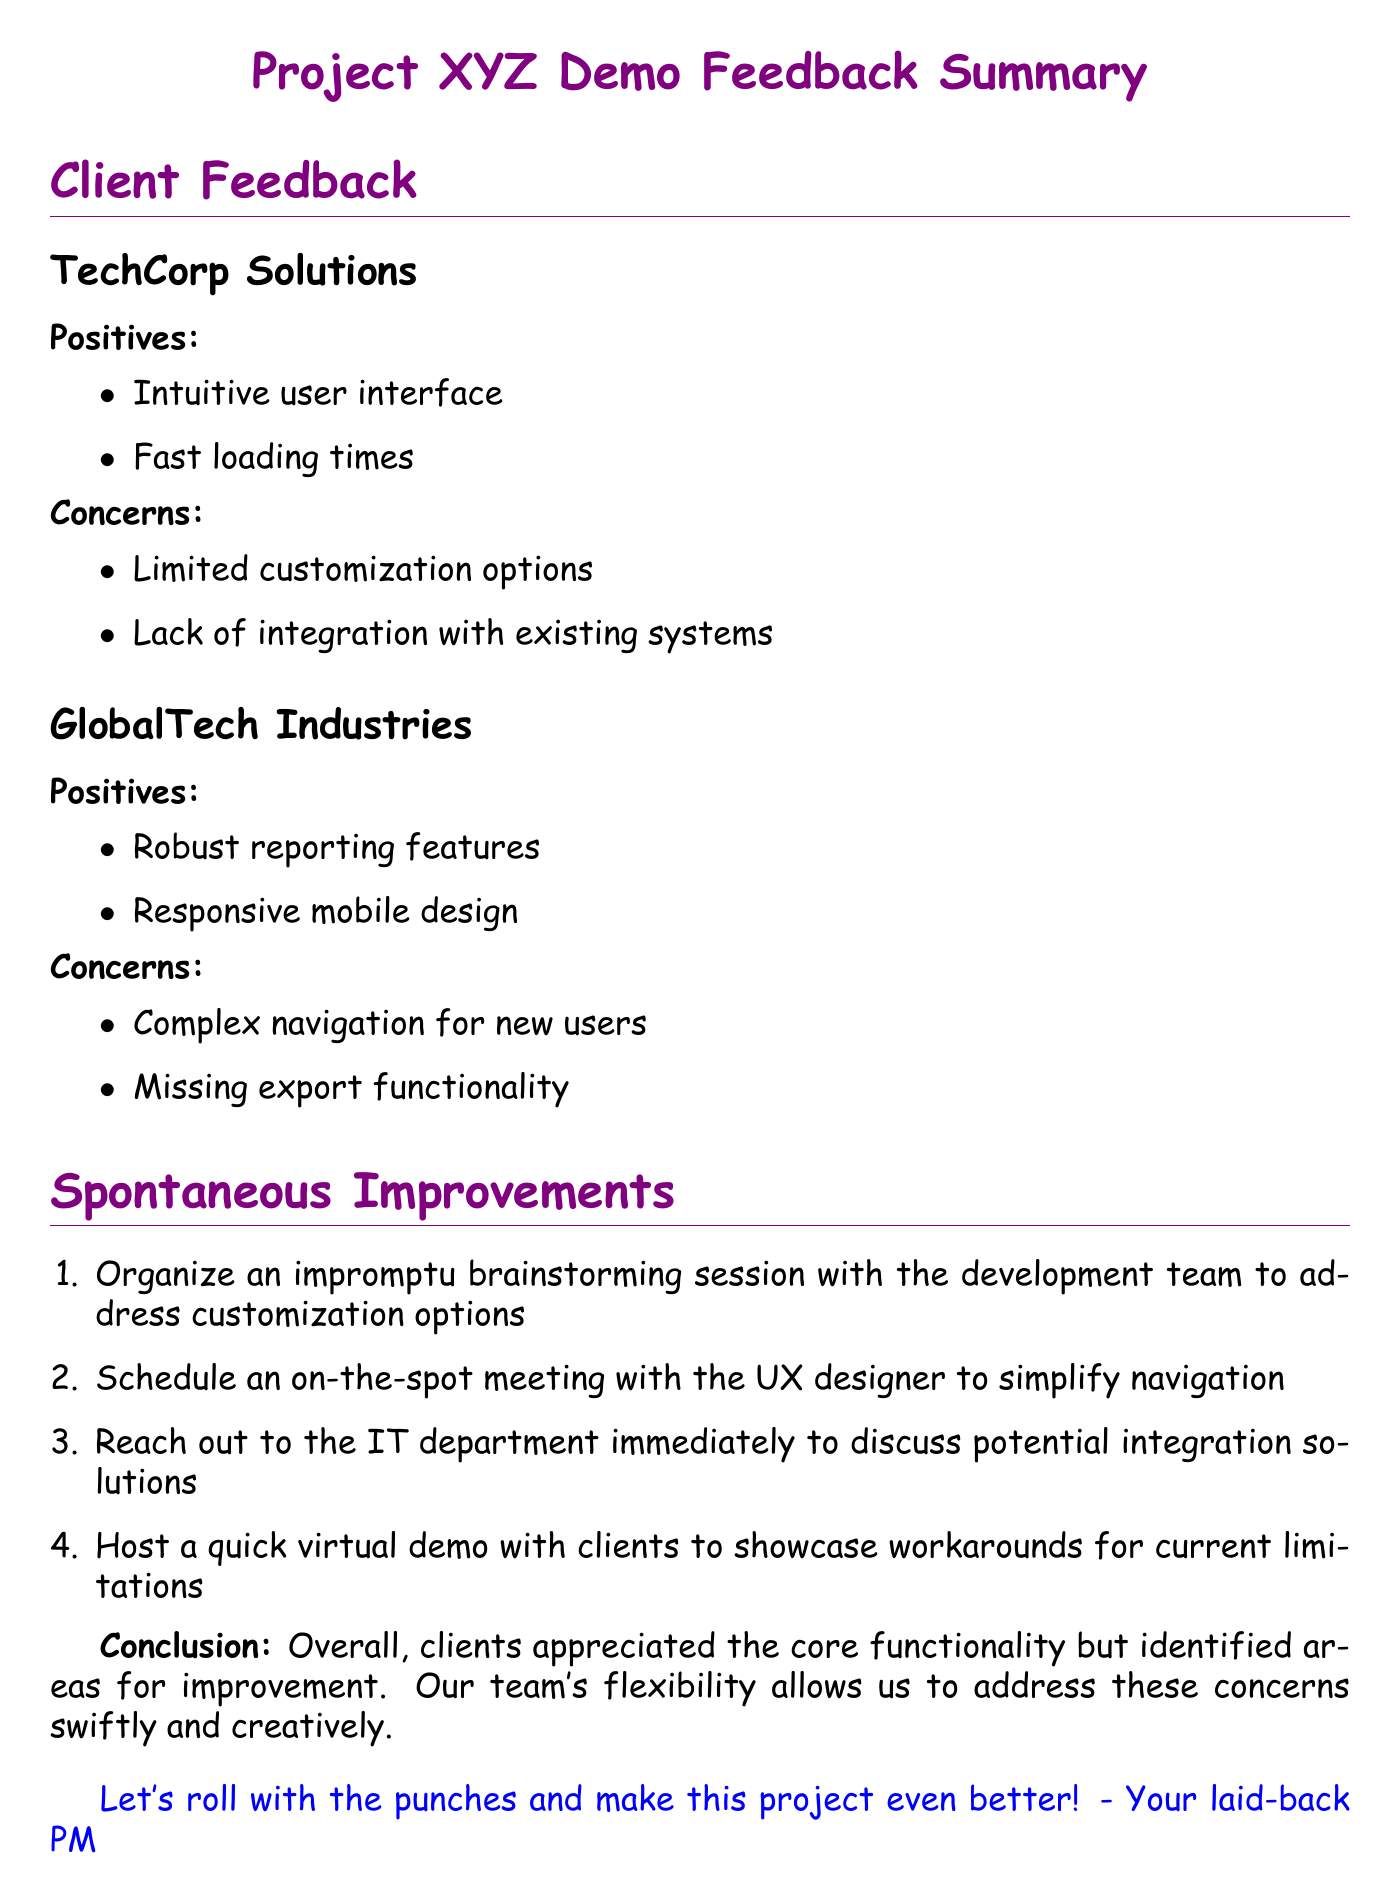what is the title of the document? The title of the document is found at the beginning, under the heading.
Answer: Project XYZ Demo Feedback Summary who provided positive feedback regarding intuitive user interface? The company that provided this feedback is listed under TechCorp Solutions.
Answer: TechCorp Solutions how many positives did GlobalTech Industries mention? This information is counted from the list under the GlobalTech Industries section.
Answer: 2 what is one of the concerns raised by TechCorp Solutions? The concerns are listed in a bullet point format in the document.
Answer: Limited customization options which spontaneous improvement involves the IT department? This improvement is specifically indicated in the list of spontaneous improvements.
Answer: Discuss potential integration solutions how many spontaneous improvements are suggested in total? This is determined by counting the items in the spontaneous improvements section.
Answer: 4 what feature was noted as complex by GlobalTech Industries? This can be found in the list of concerns for GlobalTech Industries.
Answer: Navigation for new users who is encouraged to host a quick virtual demo? The individual encouraged is specified in the context of the improvements.
Answer: Not specified here 